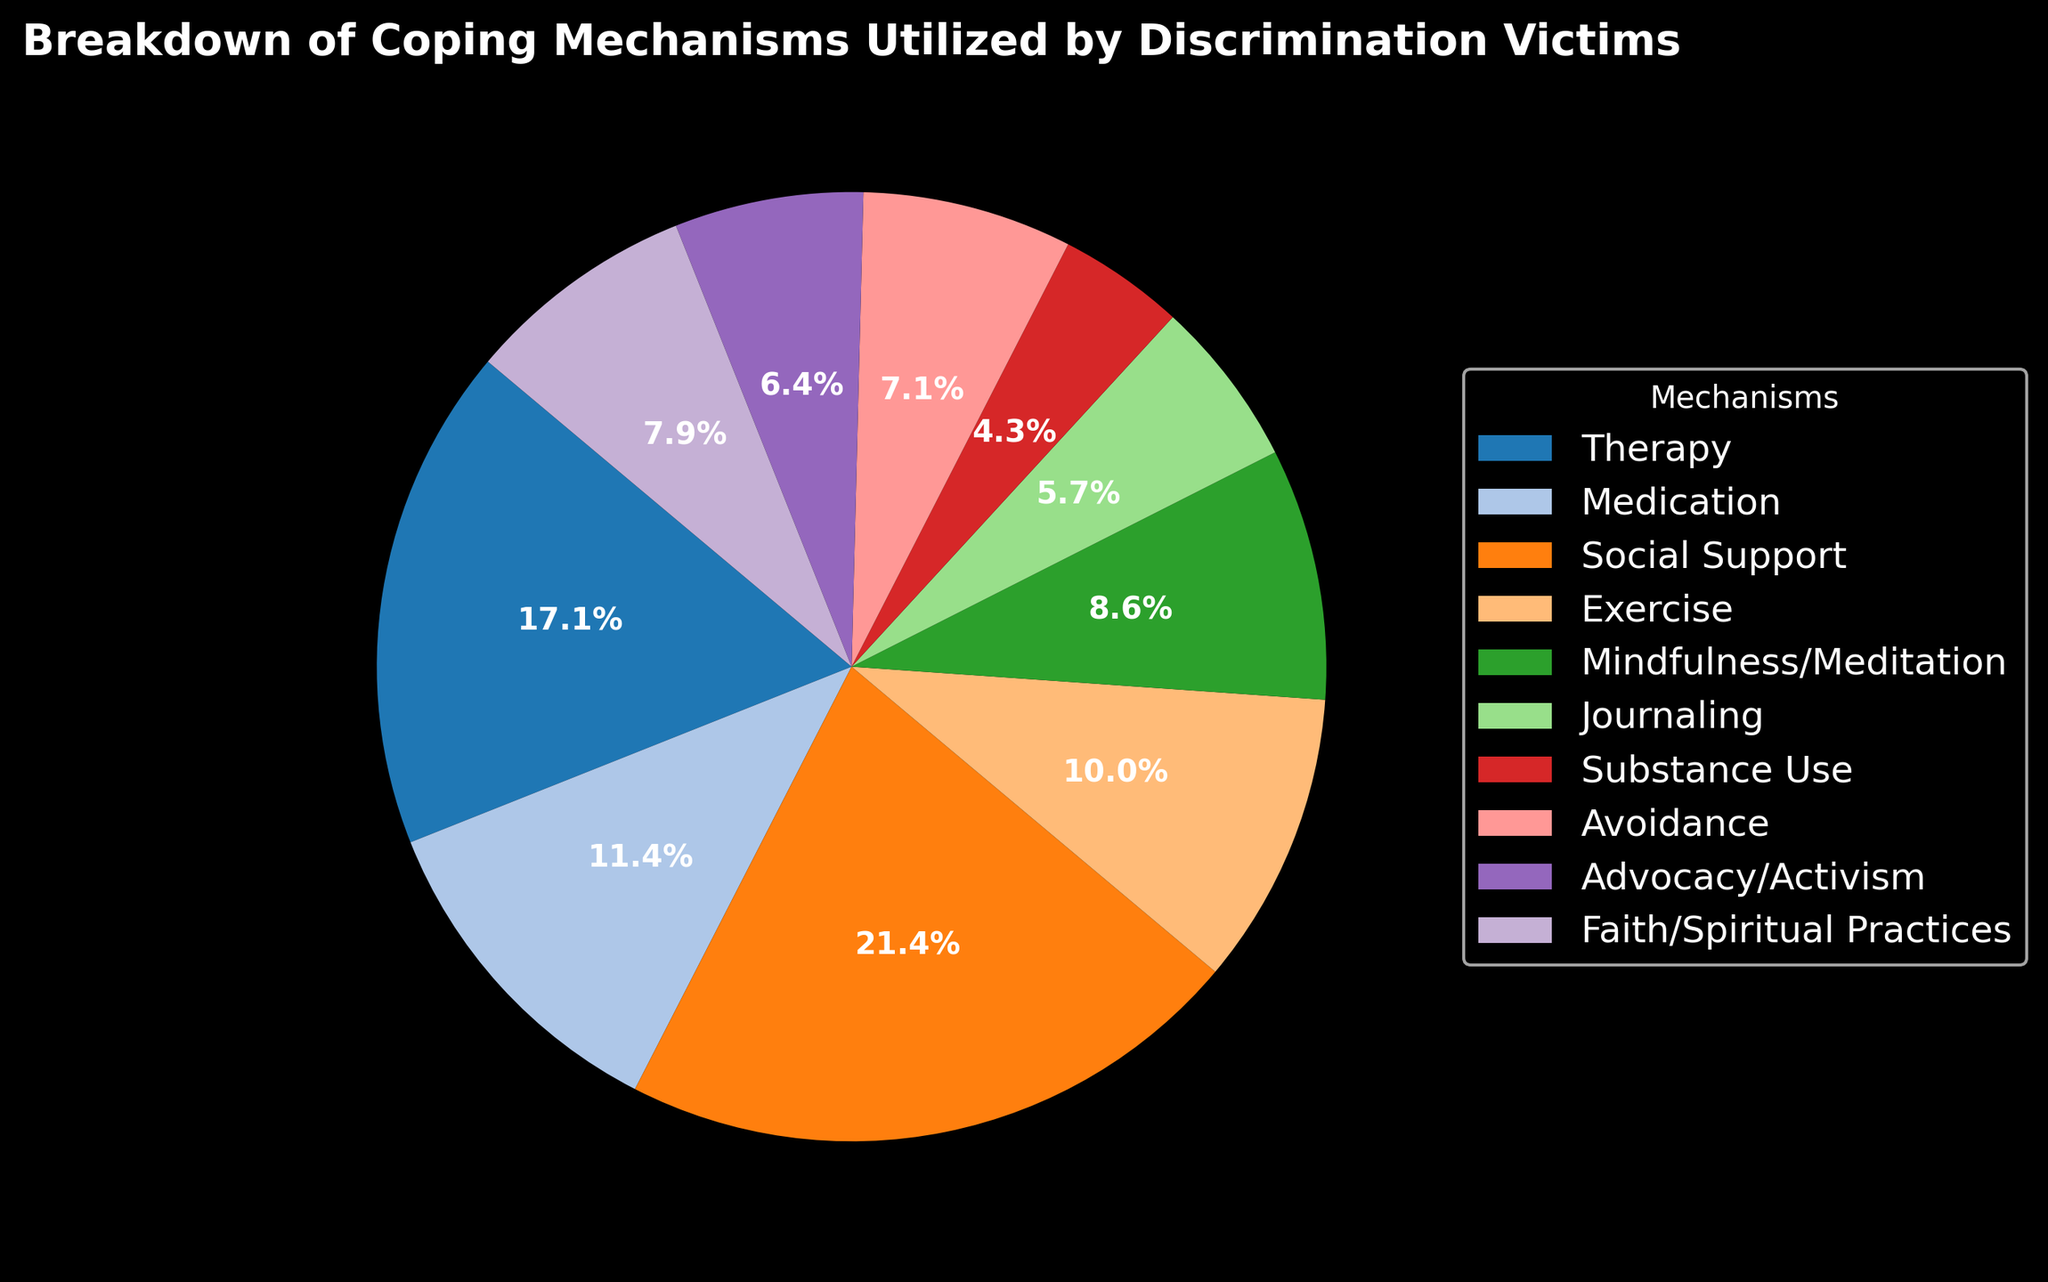What's the most utilized coping mechanism? The largest segment of the pie chart represents "Social Support," indicating it is the most utilized coping mechanism.
Answer: Social Support How much more popular is social support compared to exercise? The percentage for social support is higher than exercise. Social support accounts for a larger part of the pie chart compared to exercise.
Answer: 80 more counts Which mechanism has the least utilization? The smallest segment of the pie chart is "Substance Use," indicating it is the least utilized coping mechanism.
Answer: Substance Use By how much does the combined usage of therapy and medication exceed that of mindfulness/meditation and journaling together? Add the counts for therapy (120) and medication (80) which is 200. Then, add the counts for mindfulness/meditation (60) and journaling (40) which is 100. The difference is 200 - 100 = 100.
Answer: 100 counts What's the percentage utilization of faith/spiritual practices? The pie chart shows the percentage for faith/spiritual practices which is 8.3% based on the chart's segment and label.
Answer: 8.3% Which has a higher utilization: advocacy/activism or avoidance? By comparing the sizes of the segments in the pie chart, avoidance has a slightly larger segment than advocacy/activism.
Answer: Avoidance Compare the usage of therapy to social support in terms of their counts. How many more people utilize social support? Social support has a count of 150, and therapy has 120. The difference is 150 - 120 = 30.
Answer: 30 more Which mechanisms fall in the mid-range (4th and 5th place in count)? Based on the sizes of the pie chart segments, avoidance and advocacy/activism are in the mid-range of utilization.
Answer: Avoidance, Advocacy/Activism What is the sum of the counts for the top three utilized mechanisms? The top three mechanisms are social support (150), therapy (120), and medication (80). Adding these counts gives 150 + 120 + 80 = 350.
Answer: 350 How does the utilization of exercise compare to mindfulness/meditation? By examining the pie chart, exercise has a slightly larger segment than mindfulness/meditation.
Answer: Exercise is higher 